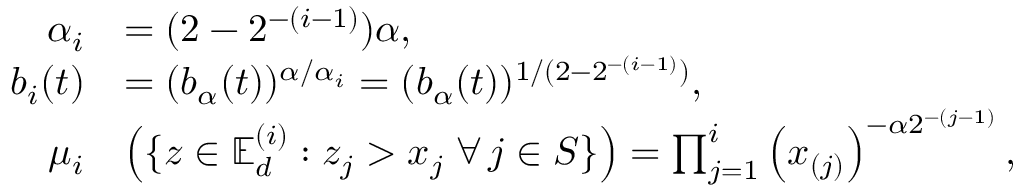<formula> <loc_0><loc_0><loc_500><loc_500>\begin{array} { r l } { \alpha _ { i } } & { = ( 2 - 2 ^ { - ( i - 1 ) } ) \alpha , } \\ { b _ { i } ( t ) } & { = ( b _ { \alpha } ( t ) ) ^ { \alpha / \alpha _ { i } } = ( b _ { \alpha } ( t ) ) ^ { 1 / ( 2 - 2 ^ { - ( i - 1 ) } ) } , } \\ { \mu _ { i } } & { \left ( \{ \boldsymbol z \in \mathbb { E } _ { d } ^ { ( i ) } \colon z _ { j } > x _ { j } \, \forall \, j \in S \} \right ) = \prod _ { j = 1 } ^ { i } \left ( { { x } _ { ( j ) } } \right ) ^ { - \alpha 2 ^ { - ( j - 1 ) } } , } \end{array}</formula> 